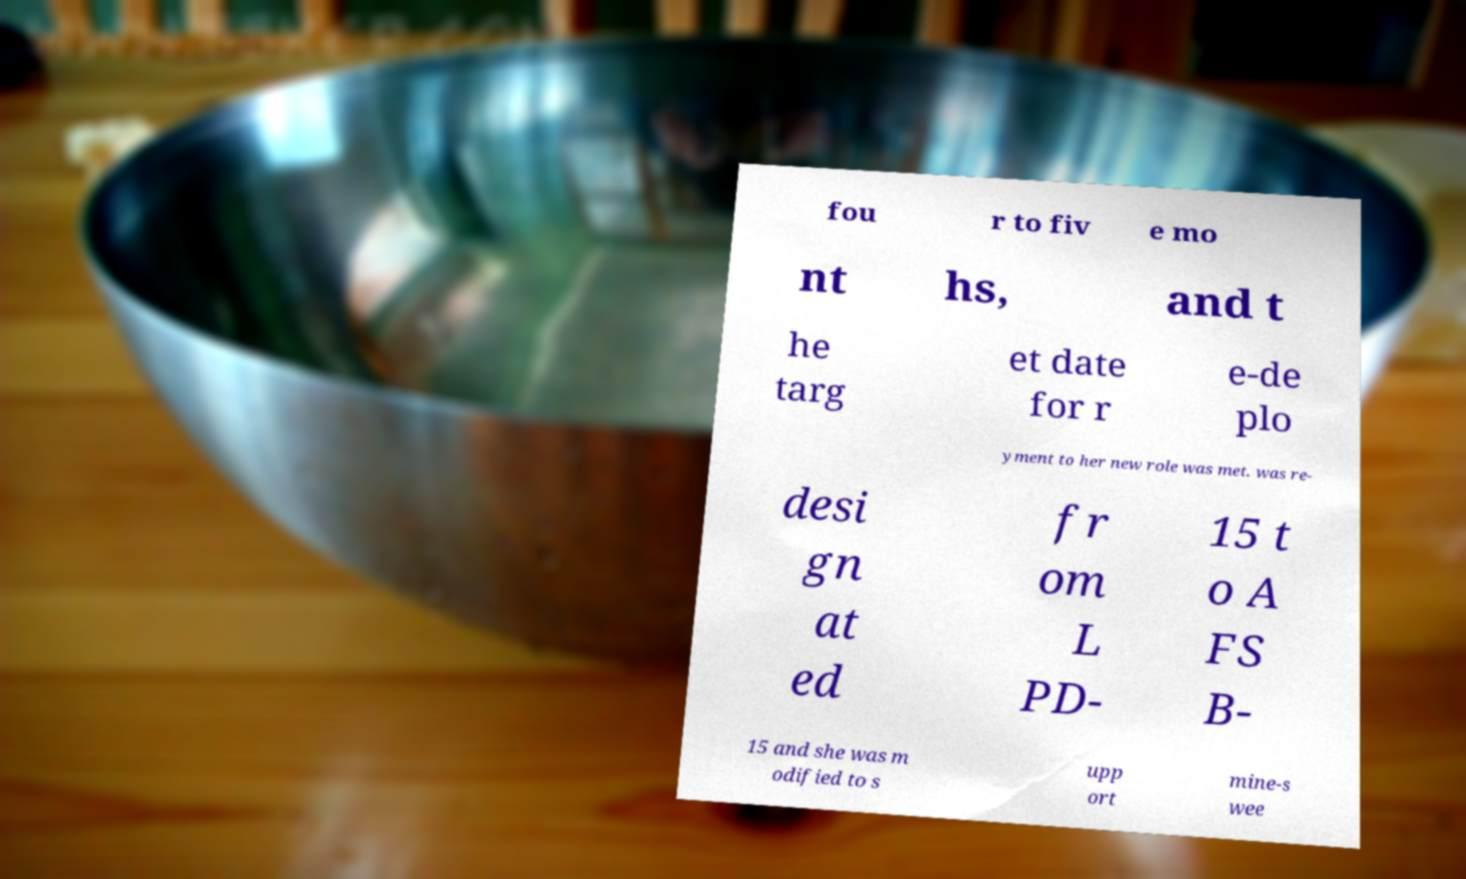Can you read and provide the text displayed in the image?This photo seems to have some interesting text. Can you extract and type it out for me? fou r to fiv e mo nt hs, and t he targ et date for r e-de plo yment to her new role was met. was re- desi gn at ed fr om L PD- 15 t o A FS B- 15 and she was m odified to s upp ort mine-s wee 